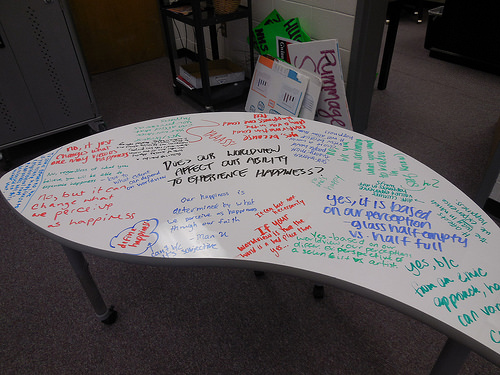<image>
Is the board on the table? No. The board is not positioned on the table. They may be near each other, but the board is not supported by or resting on top of the table. Is the rummage sign in front of the table? No. The rummage sign is not in front of the table. The spatial positioning shows a different relationship between these objects. 